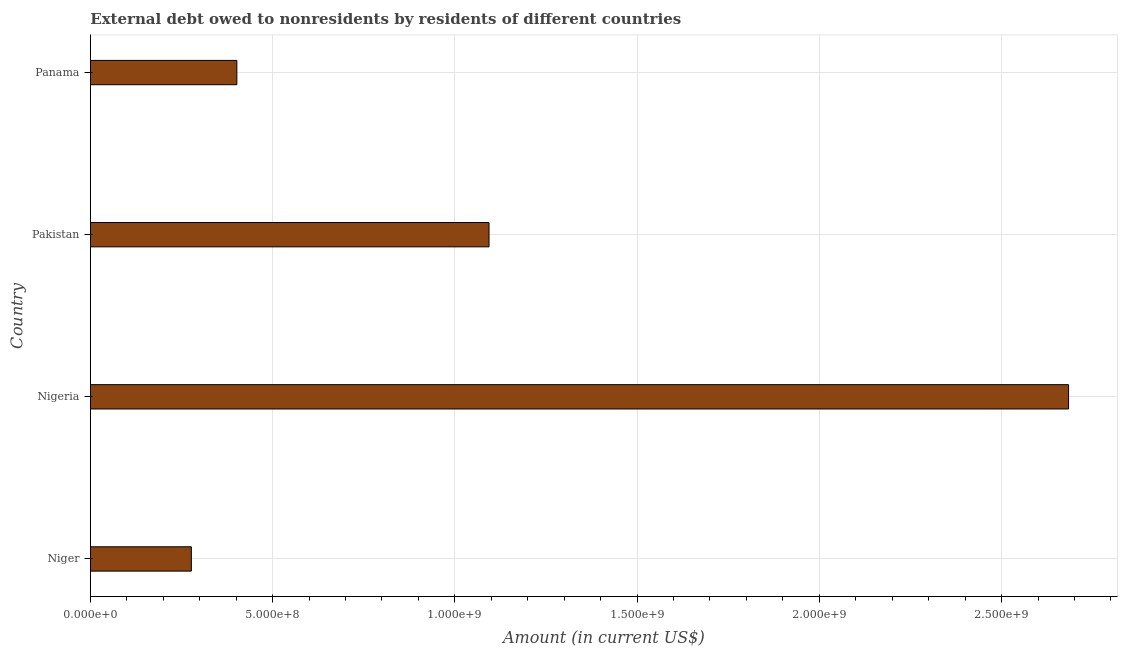What is the title of the graph?
Ensure brevity in your answer.  External debt owed to nonresidents by residents of different countries. What is the label or title of the Y-axis?
Your answer should be very brief. Country. What is the debt in Niger?
Ensure brevity in your answer.  2.77e+08. Across all countries, what is the maximum debt?
Your answer should be compact. 2.68e+09. Across all countries, what is the minimum debt?
Your answer should be very brief. 2.77e+08. In which country was the debt maximum?
Provide a succinct answer. Nigeria. In which country was the debt minimum?
Make the answer very short. Niger. What is the sum of the debt?
Ensure brevity in your answer.  4.46e+09. What is the difference between the debt in Niger and Panama?
Keep it short and to the point. -1.25e+08. What is the average debt per country?
Your response must be concise. 1.11e+09. What is the median debt?
Your answer should be very brief. 7.48e+08. In how many countries, is the debt greater than 2700000000 US$?
Your response must be concise. 0. What is the ratio of the debt in Nigeria to that in Panama?
Provide a succinct answer. 6.68. What is the difference between the highest and the second highest debt?
Offer a very short reply. 1.59e+09. Is the sum of the debt in Niger and Panama greater than the maximum debt across all countries?
Provide a short and direct response. No. What is the difference between the highest and the lowest debt?
Keep it short and to the point. 2.41e+09. In how many countries, is the debt greater than the average debt taken over all countries?
Give a very brief answer. 1. How many bars are there?
Keep it short and to the point. 4. Are all the bars in the graph horizontal?
Give a very brief answer. Yes. How many countries are there in the graph?
Provide a succinct answer. 4. What is the difference between two consecutive major ticks on the X-axis?
Keep it short and to the point. 5.00e+08. Are the values on the major ticks of X-axis written in scientific E-notation?
Offer a very short reply. Yes. What is the Amount (in current US$) in Niger?
Ensure brevity in your answer.  2.77e+08. What is the Amount (in current US$) of Nigeria?
Your response must be concise. 2.68e+09. What is the Amount (in current US$) in Pakistan?
Offer a terse response. 1.09e+09. What is the Amount (in current US$) of Panama?
Your answer should be very brief. 4.02e+08. What is the difference between the Amount (in current US$) in Niger and Nigeria?
Your answer should be compact. -2.41e+09. What is the difference between the Amount (in current US$) in Niger and Pakistan?
Your answer should be compact. -8.17e+08. What is the difference between the Amount (in current US$) in Niger and Panama?
Offer a very short reply. -1.25e+08. What is the difference between the Amount (in current US$) in Nigeria and Pakistan?
Your response must be concise. 1.59e+09. What is the difference between the Amount (in current US$) in Nigeria and Panama?
Make the answer very short. 2.28e+09. What is the difference between the Amount (in current US$) in Pakistan and Panama?
Your answer should be compact. 6.92e+08. What is the ratio of the Amount (in current US$) in Niger to that in Nigeria?
Provide a succinct answer. 0.1. What is the ratio of the Amount (in current US$) in Niger to that in Pakistan?
Provide a short and direct response. 0.25. What is the ratio of the Amount (in current US$) in Niger to that in Panama?
Give a very brief answer. 0.69. What is the ratio of the Amount (in current US$) in Nigeria to that in Pakistan?
Make the answer very short. 2.45. What is the ratio of the Amount (in current US$) in Nigeria to that in Panama?
Ensure brevity in your answer.  6.68. What is the ratio of the Amount (in current US$) in Pakistan to that in Panama?
Provide a short and direct response. 2.72. 